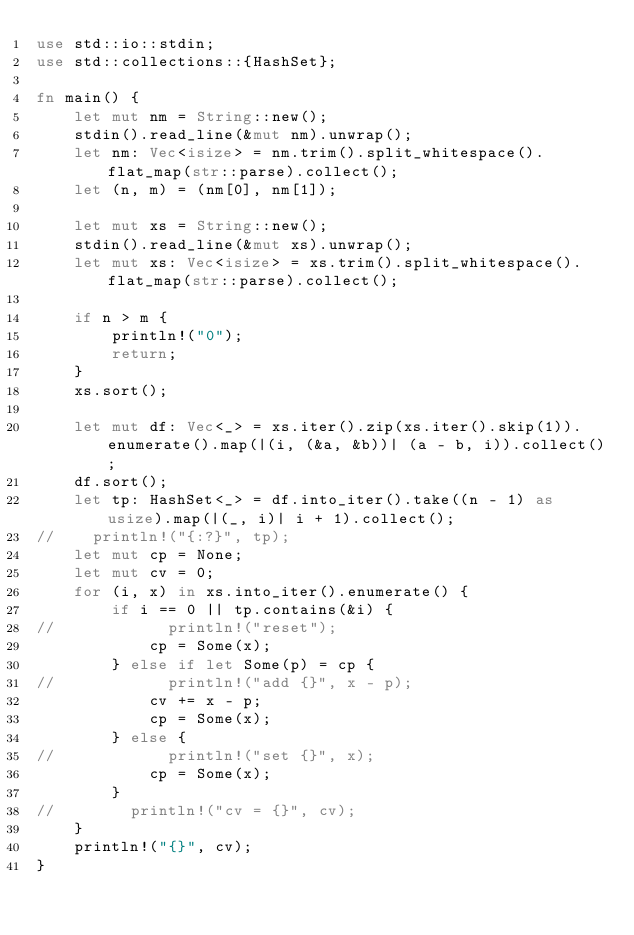<code> <loc_0><loc_0><loc_500><loc_500><_Rust_>use std::io::stdin;
use std::collections::{HashSet};

fn main() {
    let mut nm = String::new();
    stdin().read_line(&mut nm).unwrap();
    let nm: Vec<isize> = nm.trim().split_whitespace().flat_map(str::parse).collect();
    let (n, m) = (nm[0], nm[1]);

    let mut xs = String::new();
    stdin().read_line(&mut xs).unwrap();
    let mut xs: Vec<isize> = xs.trim().split_whitespace().flat_map(str::parse).collect();

    if n > m {
        println!("0");
        return;
    }
    xs.sort();

    let mut df: Vec<_> = xs.iter().zip(xs.iter().skip(1)).enumerate().map(|(i, (&a, &b))| (a - b, i)).collect();
    df.sort();
    let tp: HashSet<_> = df.into_iter().take((n - 1) as usize).map(|(_, i)| i + 1).collect();
//    println!("{:?}", tp);
    let mut cp = None;
    let mut cv = 0;
    for (i, x) in xs.into_iter().enumerate() {
        if i == 0 || tp.contains(&i) {
//            println!("reset");
            cp = Some(x);
        } else if let Some(p) = cp {
//            println!("add {}", x - p);
            cv += x - p;
            cp = Some(x);
        } else {
//            println!("set {}", x);
            cp = Some(x);
        }
//        println!("cv = {}", cv);
    }
    println!("{}", cv);
}
</code> 